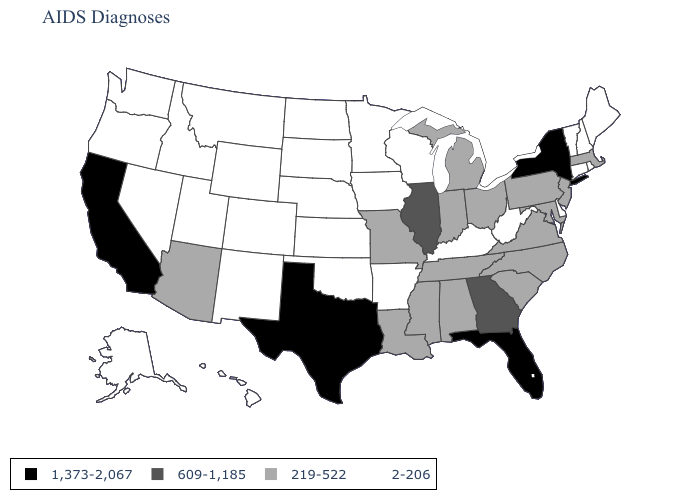Does California have the highest value in the West?
Short answer required. Yes. Which states have the highest value in the USA?
Keep it brief. California, Florida, New York, Texas. What is the value of Georgia?
Be succinct. 609-1,185. Among the states that border Kansas , which have the highest value?
Be succinct. Missouri. What is the value of South Carolina?
Give a very brief answer. 219-522. Name the states that have a value in the range 1,373-2,067?
Be succinct. California, Florida, New York, Texas. Which states have the lowest value in the USA?
Short answer required. Alaska, Arkansas, Colorado, Connecticut, Delaware, Hawaii, Idaho, Iowa, Kansas, Kentucky, Maine, Minnesota, Montana, Nebraska, Nevada, New Hampshire, New Mexico, North Dakota, Oklahoma, Oregon, Rhode Island, South Dakota, Utah, Vermont, Washington, West Virginia, Wisconsin, Wyoming. Which states have the lowest value in the West?
Concise answer only. Alaska, Colorado, Hawaii, Idaho, Montana, Nevada, New Mexico, Oregon, Utah, Washington, Wyoming. Does Wisconsin have the lowest value in the MidWest?
Be succinct. Yes. What is the value of Michigan?
Write a very short answer. 219-522. What is the value of Arkansas?
Short answer required. 2-206. What is the highest value in the USA?
Keep it brief. 1,373-2,067. Which states have the highest value in the USA?
Quick response, please. California, Florida, New York, Texas. Name the states that have a value in the range 219-522?
Short answer required. Alabama, Arizona, Indiana, Louisiana, Maryland, Massachusetts, Michigan, Mississippi, Missouri, New Jersey, North Carolina, Ohio, Pennsylvania, South Carolina, Tennessee, Virginia. 